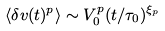<formula> <loc_0><loc_0><loc_500><loc_500>\langle \delta v ( t ) ^ { p } \rangle \sim V _ { 0 } ^ { p } ( t / \tau _ { 0 } ) ^ { \xi _ { p } }</formula> 